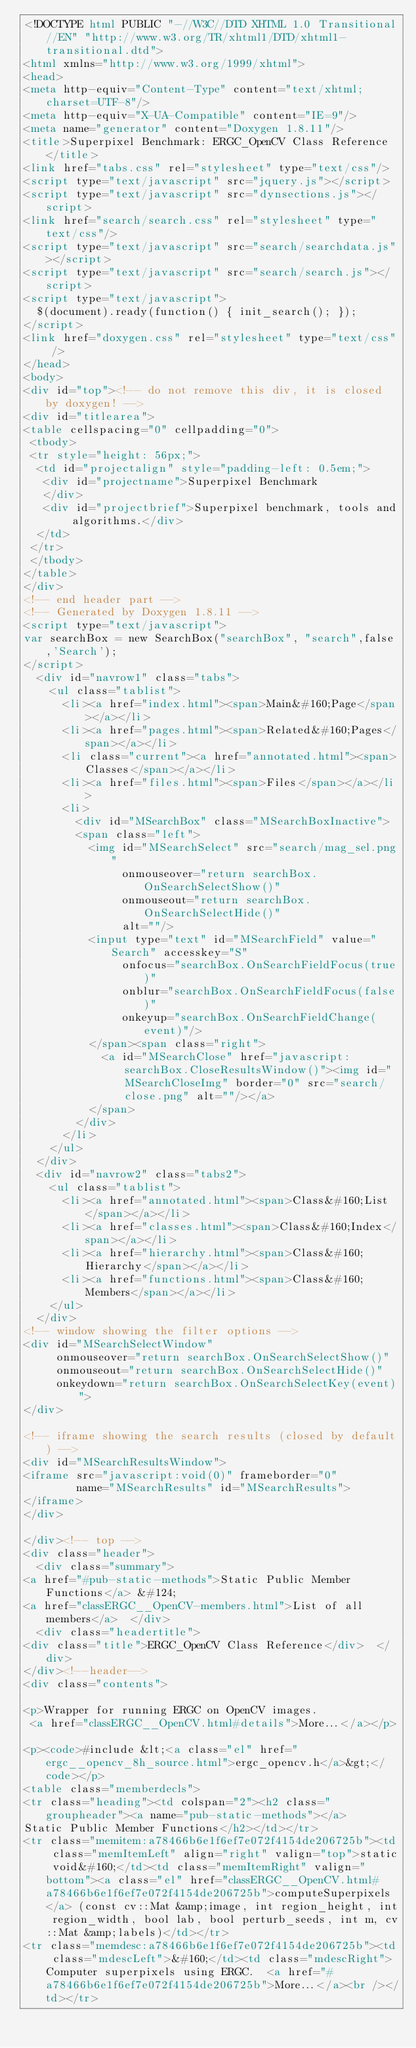<code> <loc_0><loc_0><loc_500><loc_500><_HTML_><!DOCTYPE html PUBLIC "-//W3C//DTD XHTML 1.0 Transitional//EN" "http://www.w3.org/TR/xhtml1/DTD/xhtml1-transitional.dtd">
<html xmlns="http://www.w3.org/1999/xhtml">
<head>
<meta http-equiv="Content-Type" content="text/xhtml;charset=UTF-8"/>
<meta http-equiv="X-UA-Compatible" content="IE=9"/>
<meta name="generator" content="Doxygen 1.8.11"/>
<title>Superpixel Benchmark: ERGC_OpenCV Class Reference</title>
<link href="tabs.css" rel="stylesheet" type="text/css"/>
<script type="text/javascript" src="jquery.js"></script>
<script type="text/javascript" src="dynsections.js"></script>
<link href="search/search.css" rel="stylesheet" type="text/css"/>
<script type="text/javascript" src="search/searchdata.js"></script>
<script type="text/javascript" src="search/search.js"></script>
<script type="text/javascript">
  $(document).ready(function() { init_search(); });
</script>
<link href="doxygen.css" rel="stylesheet" type="text/css" />
</head>
<body>
<div id="top"><!-- do not remove this div, it is closed by doxygen! -->
<div id="titlearea">
<table cellspacing="0" cellpadding="0">
 <tbody>
 <tr style="height: 56px;">
  <td id="projectalign" style="padding-left: 0.5em;">
   <div id="projectname">Superpixel Benchmark
   </div>
   <div id="projectbrief">Superpixel benchmark, tools and algorithms.</div>
  </td>
 </tr>
 </tbody>
</table>
</div>
<!-- end header part -->
<!-- Generated by Doxygen 1.8.11 -->
<script type="text/javascript">
var searchBox = new SearchBox("searchBox", "search",false,'Search');
</script>
  <div id="navrow1" class="tabs">
    <ul class="tablist">
      <li><a href="index.html"><span>Main&#160;Page</span></a></li>
      <li><a href="pages.html"><span>Related&#160;Pages</span></a></li>
      <li class="current"><a href="annotated.html"><span>Classes</span></a></li>
      <li><a href="files.html"><span>Files</span></a></li>
      <li>
        <div id="MSearchBox" class="MSearchBoxInactive">
        <span class="left">
          <img id="MSearchSelect" src="search/mag_sel.png"
               onmouseover="return searchBox.OnSearchSelectShow()"
               onmouseout="return searchBox.OnSearchSelectHide()"
               alt=""/>
          <input type="text" id="MSearchField" value="Search" accesskey="S"
               onfocus="searchBox.OnSearchFieldFocus(true)" 
               onblur="searchBox.OnSearchFieldFocus(false)" 
               onkeyup="searchBox.OnSearchFieldChange(event)"/>
          </span><span class="right">
            <a id="MSearchClose" href="javascript:searchBox.CloseResultsWindow()"><img id="MSearchCloseImg" border="0" src="search/close.png" alt=""/></a>
          </span>
        </div>
      </li>
    </ul>
  </div>
  <div id="navrow2" class="tabs2">
    <ul class="tablist">
      <li><a href="annotated.html"><span>Class&#160;List</span></a></li>
      <li><a href="classes.html"><span>Class&#160;Index</span></a></li>
      <li><a href="hierarchy.html"><span>Class&#160;Hierarchy</span></a></li>
      <li><a href="functions.html"><span>Class&#160;Members</span></a></li>
    </ul>
  </div>
<!-- window showing the filter options -->
<div id="MSearchSelectWindow"
     onmouseover="return searchBox.OnSearchSelectShow()"
     onmouseout="return searchBox.OnSearchSelectHide()"
     onkeydown="return searchBox.OnSearchSelectKey(event)">
</div>

<!-- iframe showing the search results (closed by default) -->
<div id="MSearchResultsWindow">
<iframe src="javascript:void(0)" frameborder="0" 
        name="MSearchResults" id="MSearchResults">
</iframe>
</div>

</div><!-- top -->
<div class="header">
  <div class="summary">
<a href="#pub-static-methods">Static Public Member Functions</a> &#124;
<a href="classERGC__OpenCV-members.html">List of all members</a>  </div>
  <div class="headertitle">
<div class="title">ERGC_OpenCV Class Reference</div>  </div>
</div><!--header-->
<div class="contents">

<p>Wrapper for running ERGC on OpenCV images.  
 <a href="classERGC__OpenCV.html#details">More...</a></p>

<p><code>#include &lt;<a class="el" href="ergc__opencv_8h_source.html">ergc_opencv.h</a>&gt;</code></p>
<table class="memberdecls">
<tr class="heading"><td colspan="2"><h2 class="groupheader"><a name="pub-static-methods"></a>
Static Public Member Functions</h2></td></tr>
<tr class="memitem:a78466b6e1f6ef7e072f4154de206725b"><td class="memItemLeft" align="right" valign="top">static void&#160;</td><td class="memItemRight" valign="bottom"><a class="el" href="classERGC__OpenCV.html#a78466b6e1f6ef7e072f4154de206725b">computeSuperpixels</a> (const cv::Mat &amp;image, int region_height, int region_width, bool lab, bool perturb_seeds, int m, cv::Mat &amp;labels)</td></tr>
<tr class="memdesc:a78466b6e1f6ef7e072f4154de206725b"><td class="mdescLeft">&#160;</td><td class="mdescRight">Computer superpixels using ERGC.  <a href="#a78466b6e1f6ef7e072f4154de206725b">More...</a><br /></td></tr></code> 